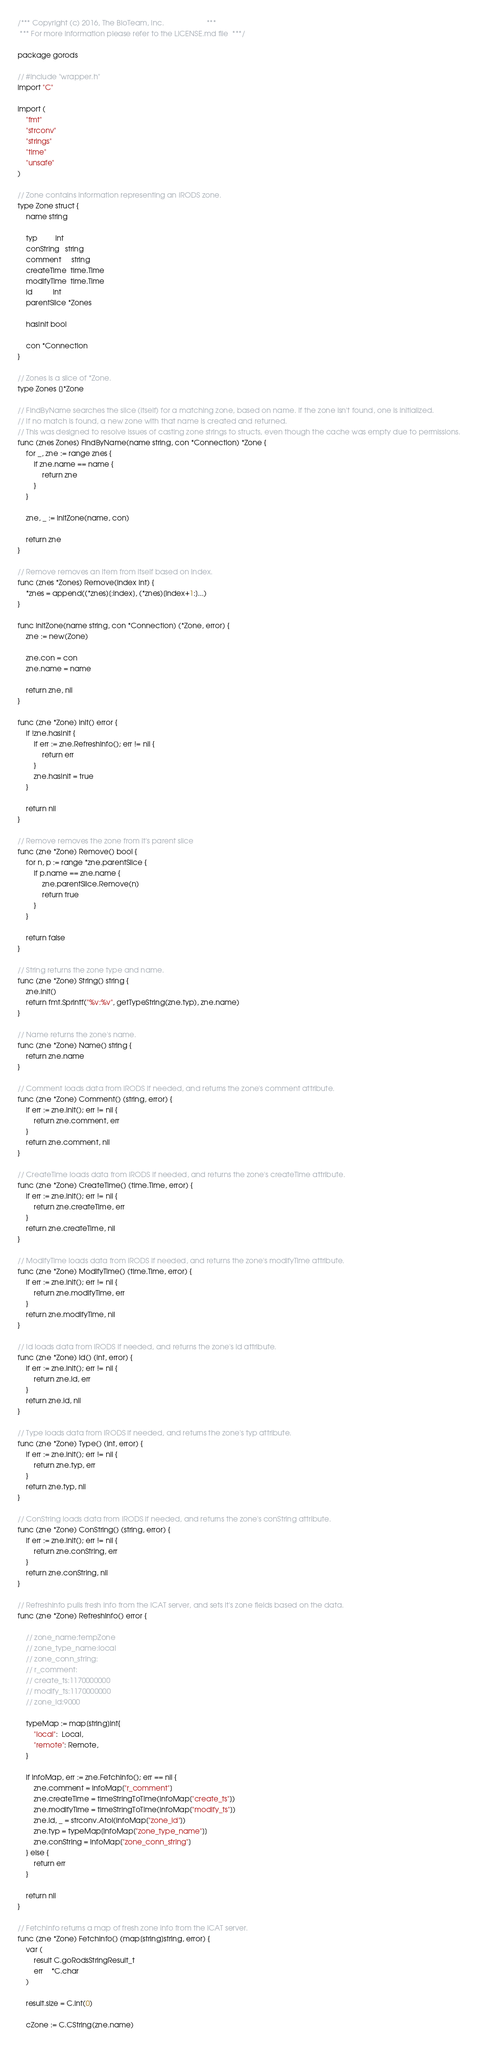<code> <loc_0><loc_0><loc_500><loc_500><_Go_>/*** Copyright (c) 2016, The BioTeam, Inc.                     ***
 *** For more information please refer to the LICENSE.md file  ***/

package gorods

// #include "wrapper.h"
import "C"

import (
	"fmt"
	"strconv"
	"strings"
	"time"
	"unsafe"
)

// Zone contains information representing an iRODS zone.
type Zone struct {
	name string

	typ         int
	conString   string
	comment     string
	createTime  time.Time
	modifyTime  time.Time
	id          int
	parentSlice *Zones

	hasInit bool

	con *Connection
}

// Zones is a slice of *Zone.
type Zones []*Zone

// FindByName searches the slice (itself) for a matching zone, based on name. If the zone isn't found, one is initialized.
// If no match is found, a new zone with that name is created and returned.
// This was designed to resolve issues of casting zone strings to structs, even though the cache was empty due to permissions.
func (znes Zones) FindByName(name string, con *Connection) *Zone {
	for _, zne := range znes {
		if zne.name == name {
			return zne
		}
	}

	zne, _ := initZone(name, con)

	return zne
}

// Remove removes an item from itself based on index.
func (znes *Zones) Remove(index int) {
	*znes = append((*znes)[:index], (*znes)[index+1:]...)
}

func initZone(name string, con *Connection) (*Zone, error) {
	zne := new(Zone)

	zne.con = con
	zne.name = name

	return zne, nil
}

func (zne *Zone) init() error {
	if !zne.hasInit {
		if err := zne.RefreshInfo(); err != nil {
			return err
		}
		zne.hasInit = true
	}

	return nil
}

// Remove removes the zone from it's parent slice
func (zne *Zone) Remove() bool {
	for n, p := range *zne.parentSlice {
		if p.name == zne.name {
			zne.parentSlice.Remove(n)
			return true
		}
	}

	return false
}

// String returns the zone type and name.
func (zne *Zone) String() string {
	zne.init()
	return fmt.Sprintf("%v:%v", getTypeString(zne.typ), zne.name)
}

// Name returns the zone's name.
func (zne *Zone) Name() string {
	return zne.name
}

// Comment loads data from iRODS if needed, and returns the zone's comment attribute.
func (zne *Zone) Comment() (string, error) {
	if err := zne.init(); err != nil {
		return zne.comment, err
	}
	return zne.comment, nil
}

// CreateTime loads data from iRODS if needed, and returns the zone's createTime attribute.
func (zne *Zone) CreateTime() (time.Time, error) {
	if err := zne.init(); err != nil {
		return zne.createTime, err
	}
	return zne.createTime, nil
}

// ModifyTime loads data from iRODS if needed, and returns the zone's modifyTime attribute.
func (zne *Zone) ModifyTime() (time.Time, error) {
	if err := zne.init(); err != nil {
		return zne.modifyTime, err
	}
	return zne.modifyTime, nil
}

// Id loads data from iRODS if needed, and returns the zone's id attribute.
func (zne *Zone) Id() (int, error) {
	if err := zne.init(); err != nil {
		return zne.id, err
	}
	return zne.id, nil
}

// Type loads data from iRODS if needed, and returns the zone's typ attribute.
func (zne *Zone) Type() (int, error) {
	if err := zne.init(); err != nil {
		return zne.typ, err
	}
	return zne.typ, nil
}

// ConString loads data from iRODS if needed, and returns the zone's conString attribute.
func (zne *Zone) ConString() (string, error) {
	if err := zne.init(); err != nil {
		return zne.conString, err
	}
	return zne.conString, nil
}

// RefreshInfo pulls fresh info from the iCAT server, and sets it's zone fields based on the data.
func (zne *Zone) RefreshInfo() error {

	// zone_name:tempZone
	// zone_type_name:local
	// zone_conn_string:
	// r_comment:
	// create_ts:1170000000
	// modify_ts:1170000000
	// zone_id:9000

	typeMap := map[string]int{
		"local":  Local,
		"remote": Remote,
	}

	if infoMap, err := zne.FetchInfo(); err == nil {
		zne.comment = infoMap["r_comment"]
		zne.createTime = timeStringToTime(infoMap["create_ts"])
		zne.modifyTime = timeStringToTime(infoMap["modify_ts"])
		zne.id, _ = strconv.Atoi(infoMap["zone_id"])
		zne.typ = typeMap[infoMap["zone_type_name"]]
		zne.conString = infoMap["zone_conn_string"]
	} else {
		return err
	}

	return nil
}

// FetchInfo returns a map of fresh zone info from the iCAT server.
func (zne *Zone) FetchInfo() (map[string]string, error) {
	var (
		result C.goRodsStringResult_t
		err    *C.char
	)

	result.size = C.int(0)

	cZone := C.CString(zne.name)</code> 